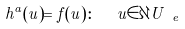Convert formula to latex. <formula><loc_0><loc_0><loc_500><loc_500>h ^ { a } ( u ) = f ( u ) \colon \ \ u \in \partial U _ { \ e }</formula> 